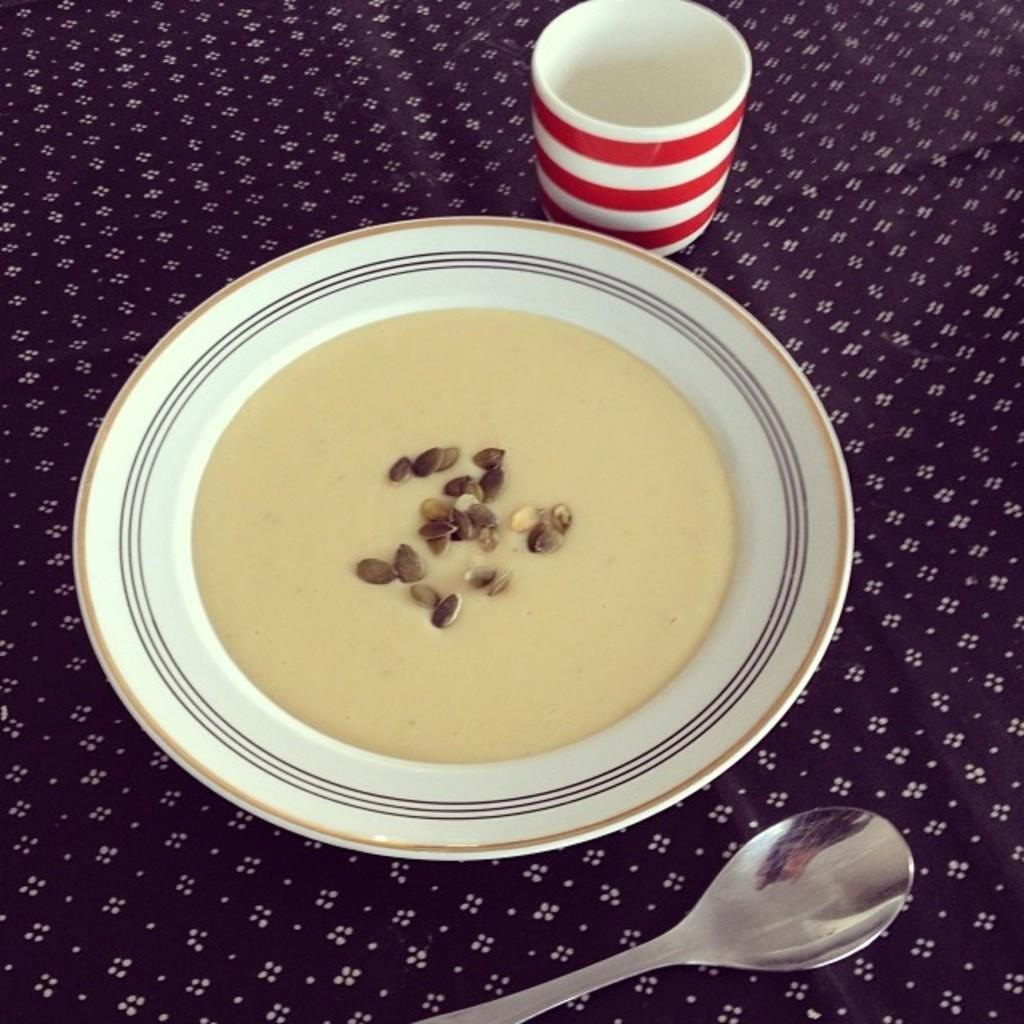What is the pattern on the cloth in the image? The cloth has white design dots in the image. What is placed on top of the cloth? There is a plate on the cloth. What is located behind the plate? There is a glass behind the plate. What utensil is in front of the plate? There is a spoon in front of the plate. What type of wool is used to make the wren's nest in the image? There is no wren or nest present in the image; it features a cloth with white design dots, a plate, a glass, and a spoon. 